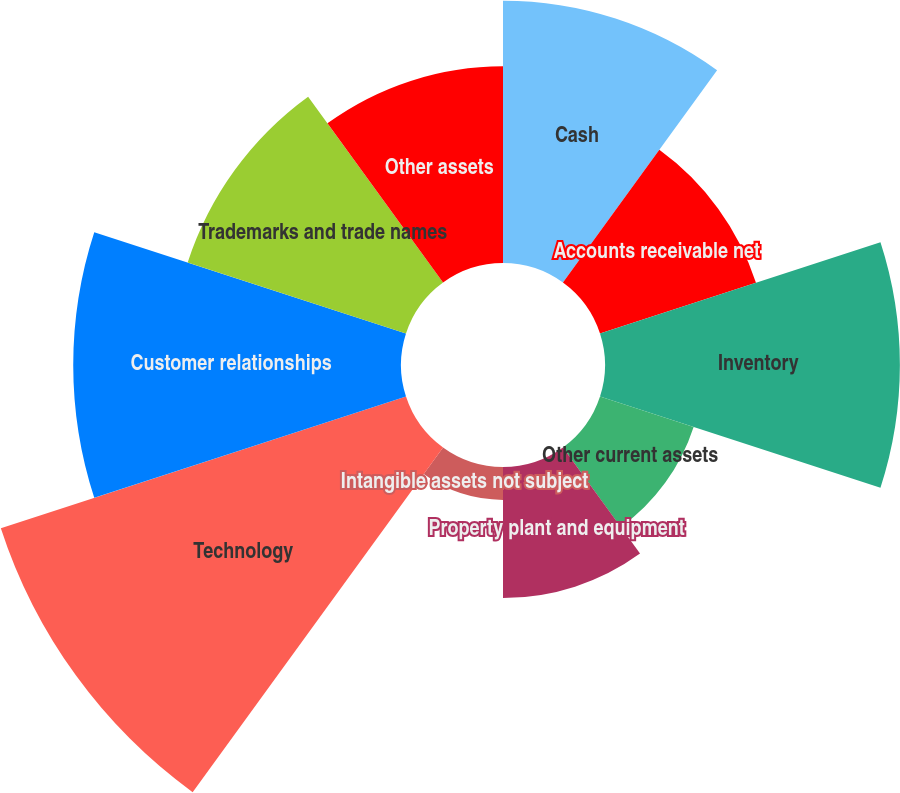Convert chart to OTSL. <chart><loc_0><loc_0><loc_500><loc_500><pie_chart><fcel>Cash<fcel>Accounts receivable net<fcel>Inventory<fcel>Other current assets<fcel>Property plant and equipment<fcel>Intangible assets not subject<fcel>Technology<fcel>Customer relationships<fcel>Trademarks and trade names<fcel>Other assets<nl><fcel>12.12%<fcel>7.58%<fcel>13.63%<fcel>4.55%<fcel>6.06%<fcel>1.52%<fcel>19.69%<fcel>15.15%<fcel>10.61%<fcel>9.09%<nl></chart> 